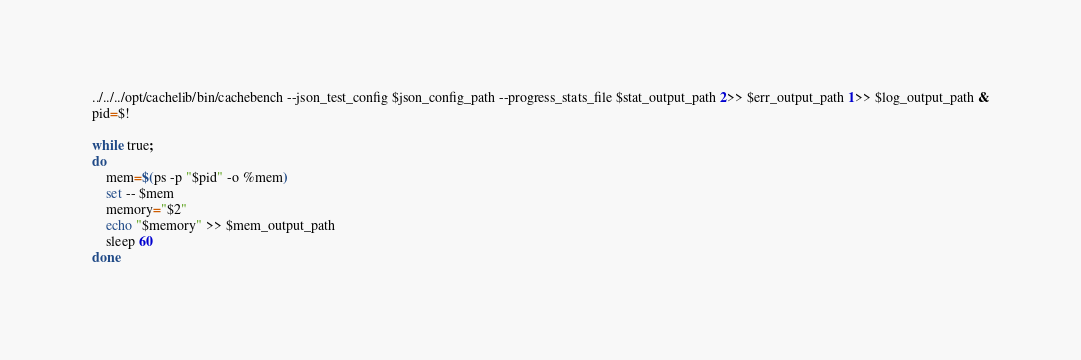<code> <loc_0><loc_0><loc_500><loc_500><_Bash_>../../../opt/cachelib/bin/cachebench --json_test_config $json_config_path --progress_stats_file $stat_output_path 2>> $err_output_path 1>> $log_output_path &
pid=$! 

while true;
do
    mem=$(ps -p "$pid" -o %mem)
    set -- $mem
    memory="$2"
    echo "$memory" >> $mem_output_path
    sleep 60
done

</code> 